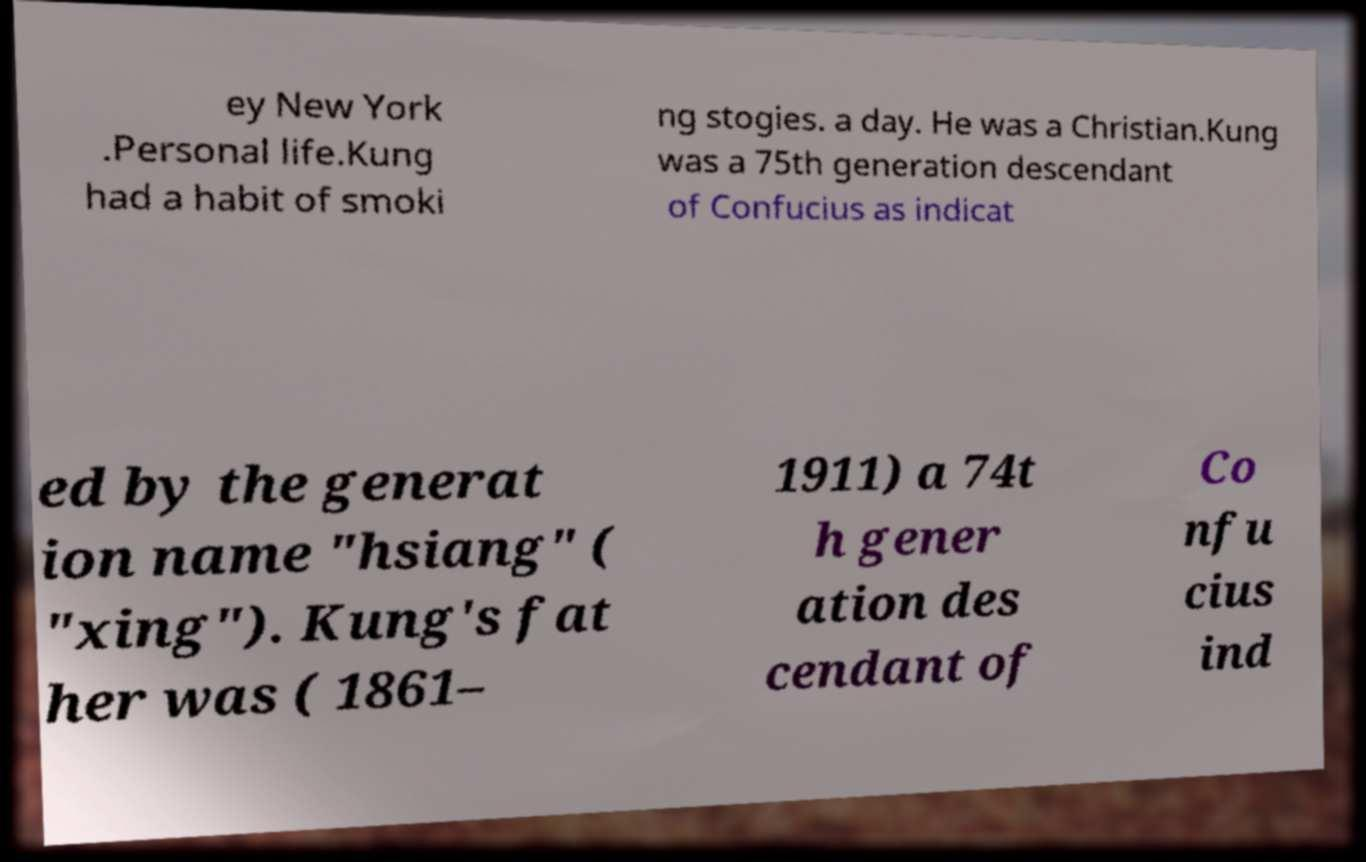Could you assist in decoding the text presented in this image and type it out clearly? ey New York .Personal life.Kung had a habit of smoki ng stogies. a day. He was a Christian.Kung was a 75th generation descendant of Confucius as indicat ed by the generat ion name "hsiang" ( "xing"). Kung's fat her was ( 1861– 1911) a 74t h gener ation des cendant of Co nfu cius ind 